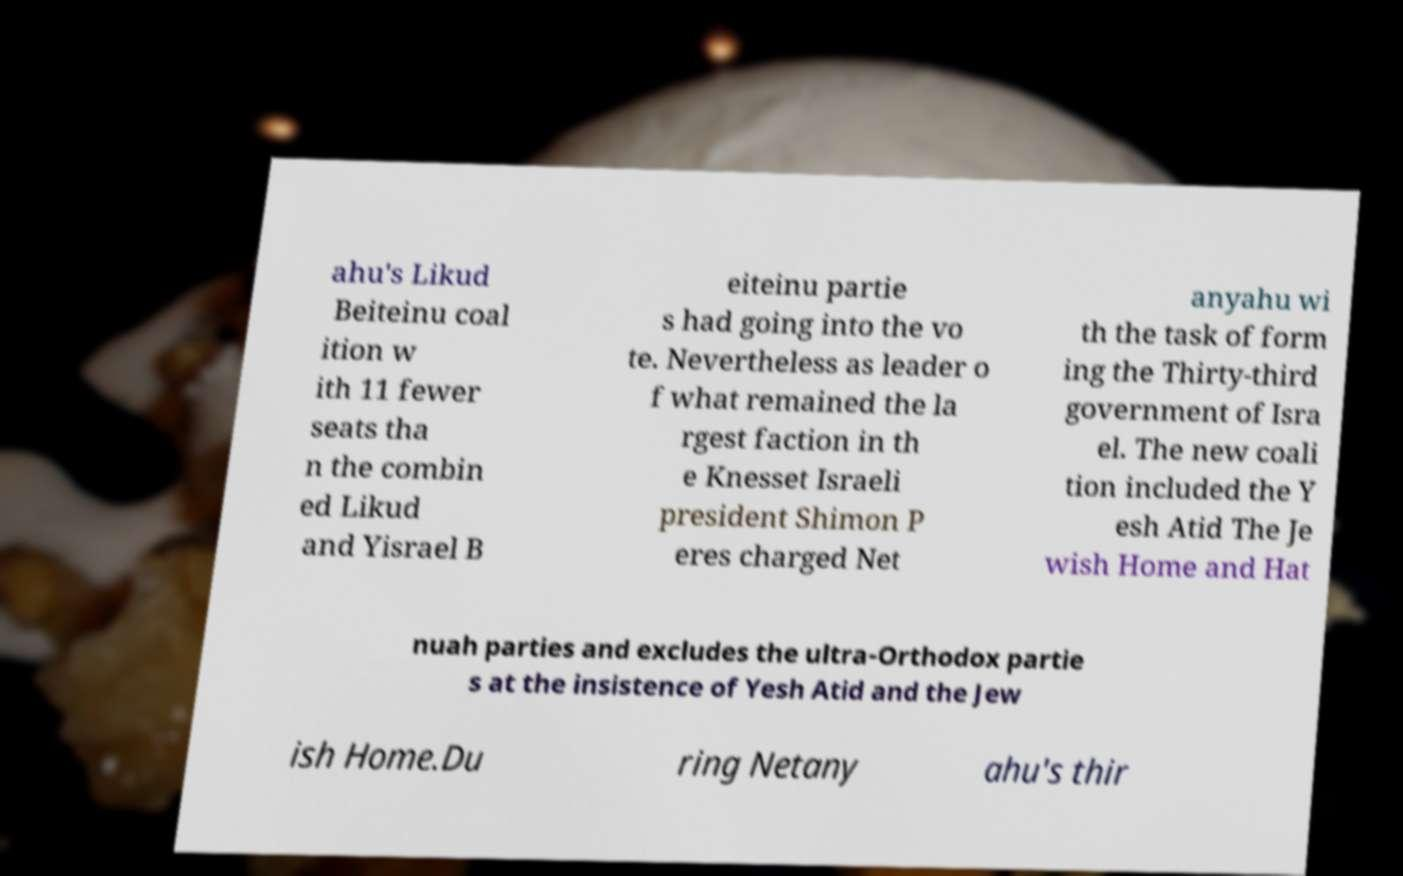What messages or text are displayed in this image? I need them in a readable, typed format. ahu's Likud Beiteinu coal ition w ith 11 fewer seats tha n the combin ed Likud and Yisrael B eiteinu partie s had going into the vo te. Nevertheless as leader o f what remained the la rgest faction in th e Knesset Israeli president Shimon P eres charged Net anyahu wi th the task of form ing the Thirty-third government of Isra el. The new coali tion included the Y esh Atid The Je wish Home and Hat nuah parties and excludes the ultra-Orthodox partie s at the insistence of Yesh Atid and the Jew ish Home.Du ring Netany ahu's thir 